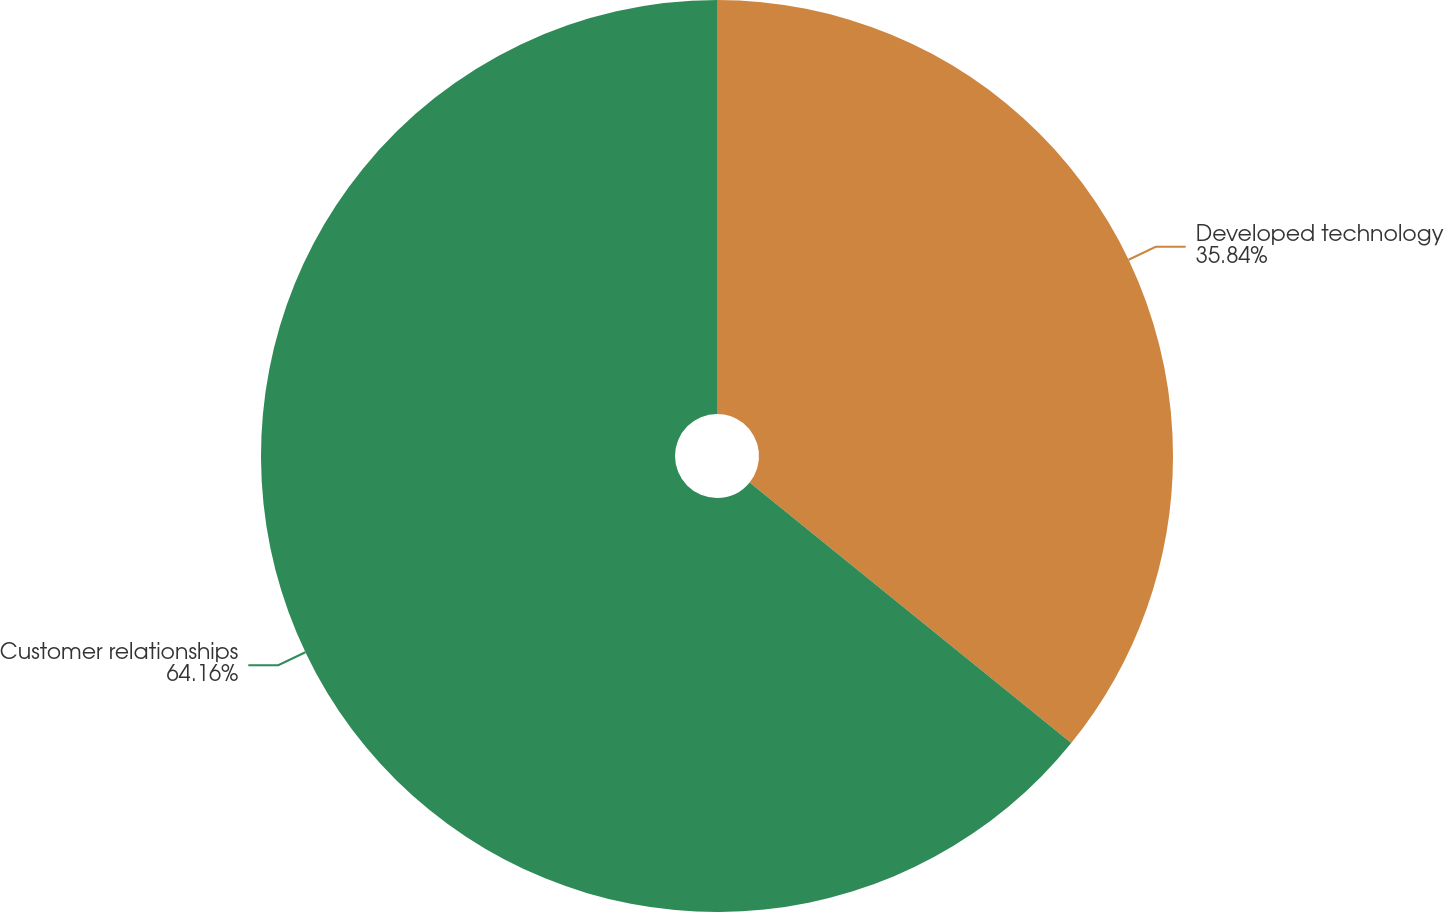<chart> <loc_0><loc_0><loc_500><loc_500><pie_chart><fcel>Developed technology<fcel>Customer relationships<nl><fcel>35.84%<fcel>64.16%<nl></chart> 